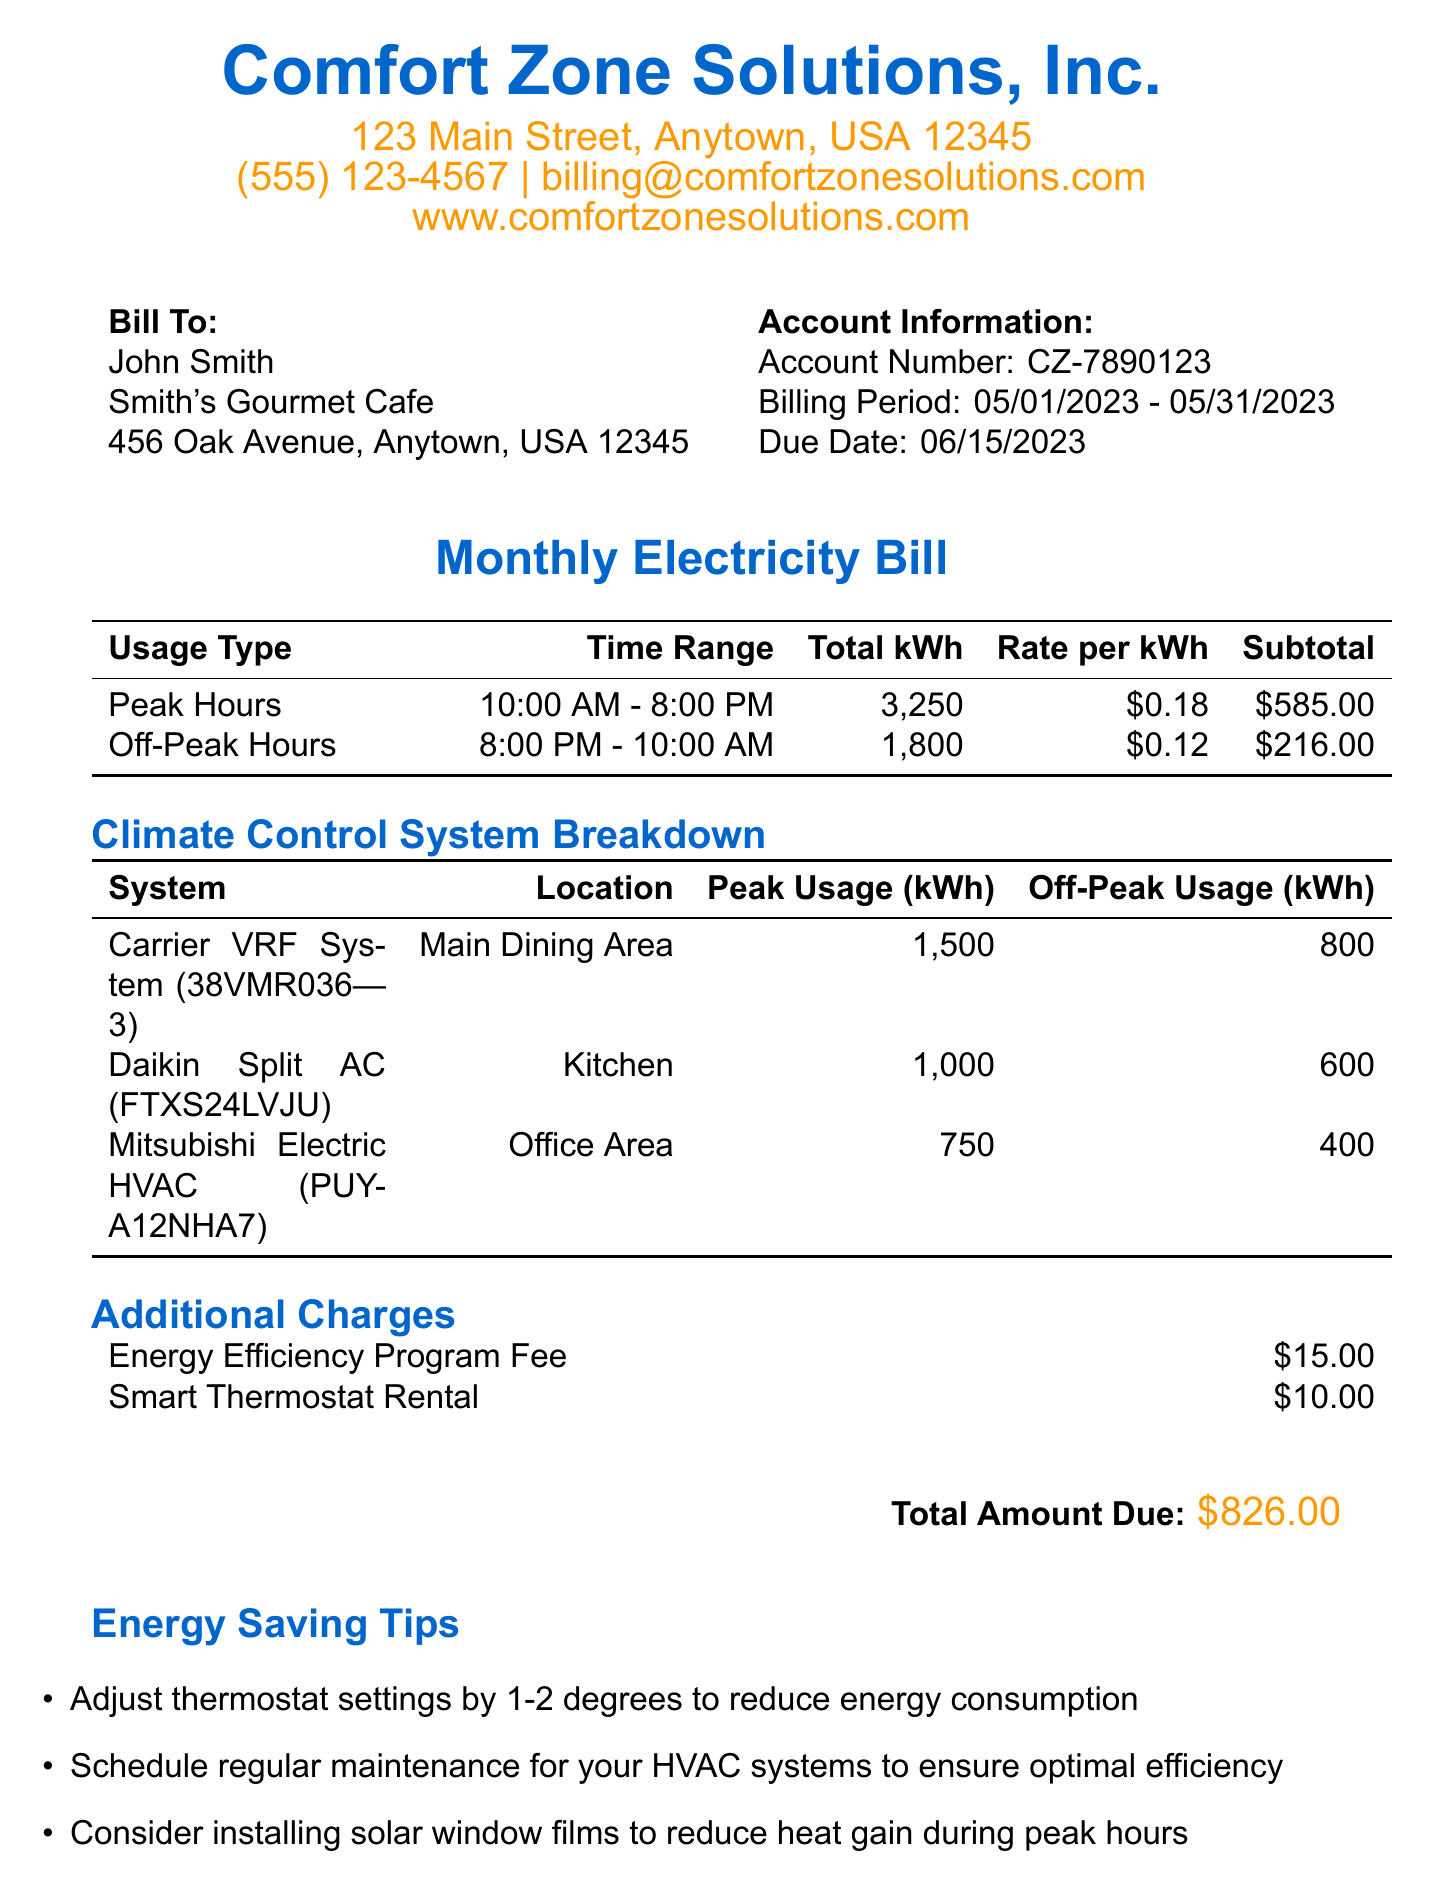What is the total amount due? The total amount due is listed clearly in the document.
Answer: $826.00 What are the peak hours? The peak hours are specified in the usage breakdown section of the document.
Answer: 10:00 AM - 8:00 PM What is the off-peak usage for the Carrier VRF System? The off-peak usage for the Carrier VRF System can be found in the climate control systems section.
Answer: 800 What is the Energy Efficiency Program Fee? This fee is part of the additional charges detailed in the document.
Answer: $15.00 How many kilowatt-hours were used during off-peak hours? The total kWh used during off-peak hours can be found in the usage breakdown section.
Answer: 1,800 Which climate control system is located in the Main Dining Area? The system located in the Main Dining Area is mentioned in the climate control systems breakdown.
Answer: Carrier VRF System When is the due date for the payment? The due date is specified in the billing information section of the document.
Answer: 2023-06-15 What is the late fee percentage? The late fee percentage is mentioned in the payment terms section of the document.
Answer: 1.5% What is the model of the Daikin Split AC? The model information is found in the climate control systems section of the document.
Answer: FTXS24LVJU 